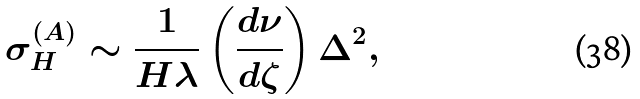Convert formula to latex. <formula><loc_0><loc_0><loc_500><loc_500>\sigma _ { H } ^ { ( A ) } \sim \frac { 1 } { H \lambda } \left ( \frac { d \nu } { d \zeta } \right ) \Delta ^ { 2 } ,</formula> 